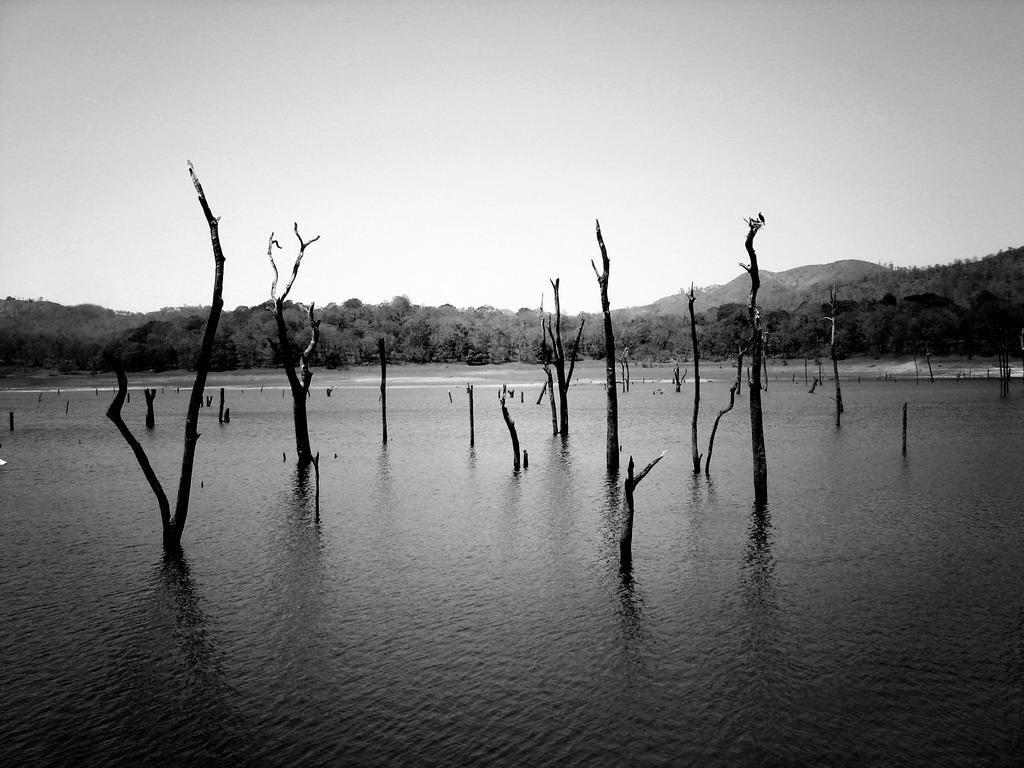What is the primary subject of the image? The primary subject of the image is trees in the water. What can be seen in the background of the image? Hills are visible in the background of the image. How is the image presented in terms of color? The image is in black and white. What type of camera is used to capture the image? The type of camera used to capture the image is not mentioned in the facts provided. Can you describe the digestion process of the trees in the water? Trees do not have a digestion process, as they are not living organisms. 